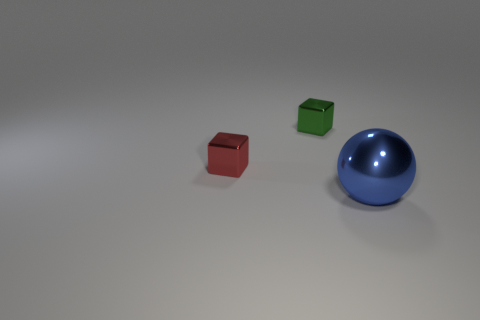Add 3 spheres. How many objects exist? 6 Subtract all balls. How many objects are left? 2 Add 2 small metallic cubes. How many small metallic cubes are left? 4 Add 3 tiny green metallic blocks. How many tiny green metallic blocks exist? 4 Subtract 0 blue cylinders. How many objects are left? 3 Subtract all green blocks. Subtract all gray cylinders. How many blocks are left? 1 Subtract all blocks. Subtract all big blue metal objects. How many objects are left? 0 